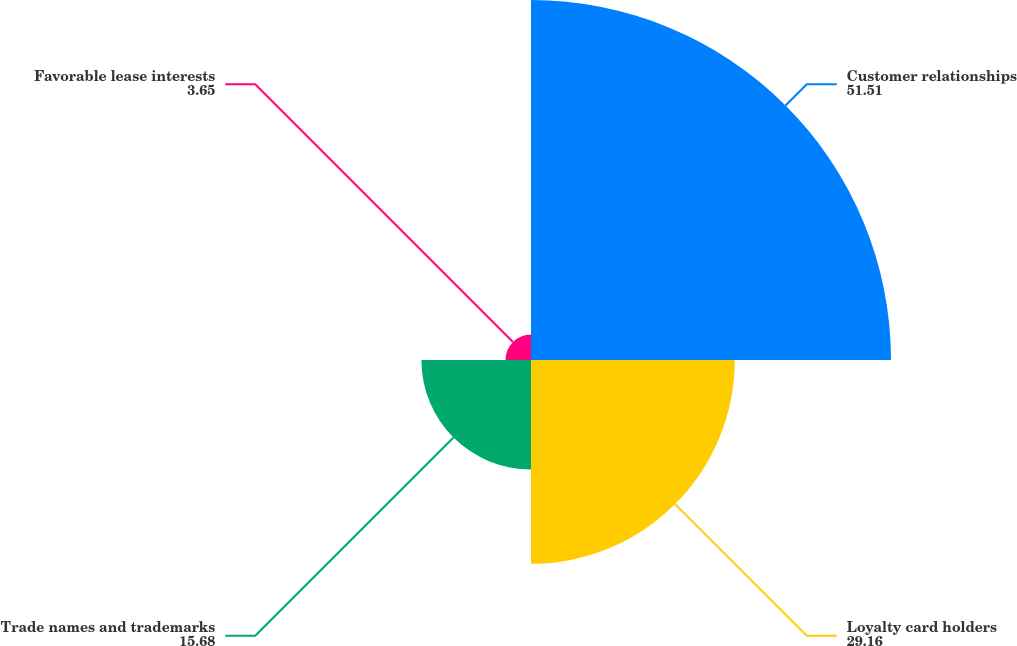<chart> <loc_0><loc_0><loc_500><loc_500><pie_chart><fcel>Customer relationships<fcel>Loyalty card holders<fcel>Trade names and trademarks<fcel>Favorable lease interests<nl><fcel>51.51%<fcel>29.16%<fcel>15.68%<fcel>3.65%<nl></chart> 